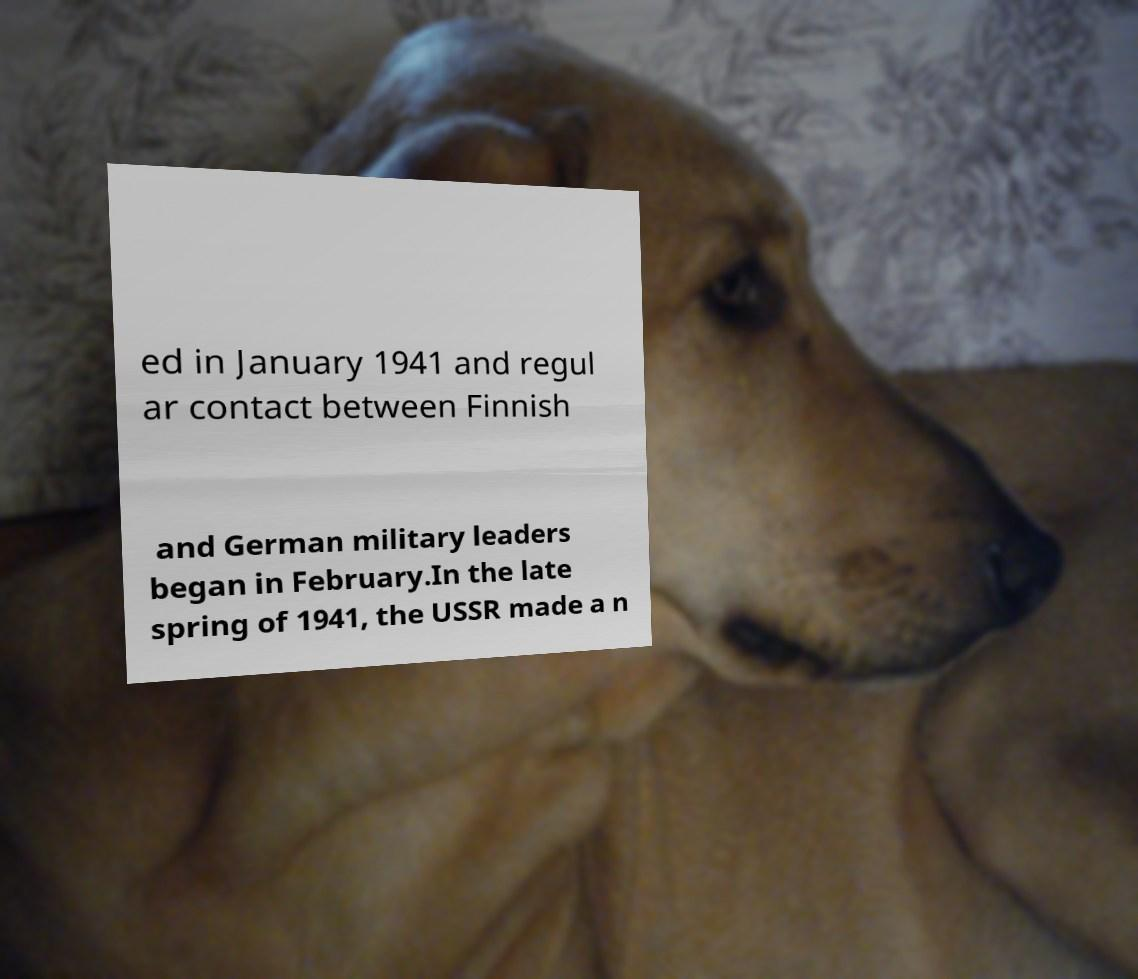For documentation purposes, I need the text within this image transcribed. Could you provide that? ed in January 1941 and regul ar contact between Finnish and German military leaders began in February.In the late spring of 1941, the USSR made a n 